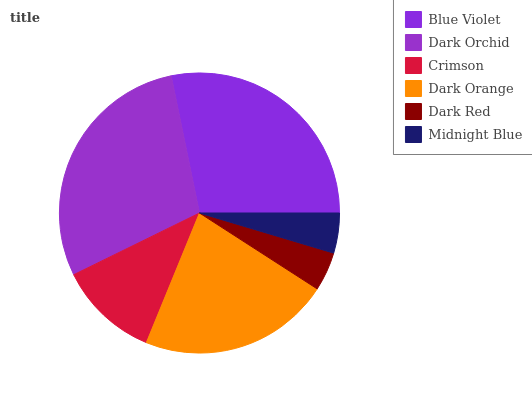Is Dark Red the minimum?
Answer yes or no. Yes. Is Dark Orchid the maximum?
Answer yes or no. Yes. Is Crimson the minimum?
Answer yes or no. No. Is Crimson the maximum?
Answer yes or no. No. Is Dark Orchid greater than Crimson?
Answer yes or no. Yes. Is Crimson less than Dark Orchid?
Answer yes or no. Yes. Is Crimson greater than Dark Orchid?
Answer yes or no. No. Is Dark Orchid less than Crimson?
Answer yes or no. No. Is Dark Orange the high median?
Answer yes or no. Yes. Is Crimson the low median?
Answer yes or no. Yes. Is Dark Orchid the high median?
Answer yes or no. No. Is Dark Orange the low median?
Answer yes or no. No. 